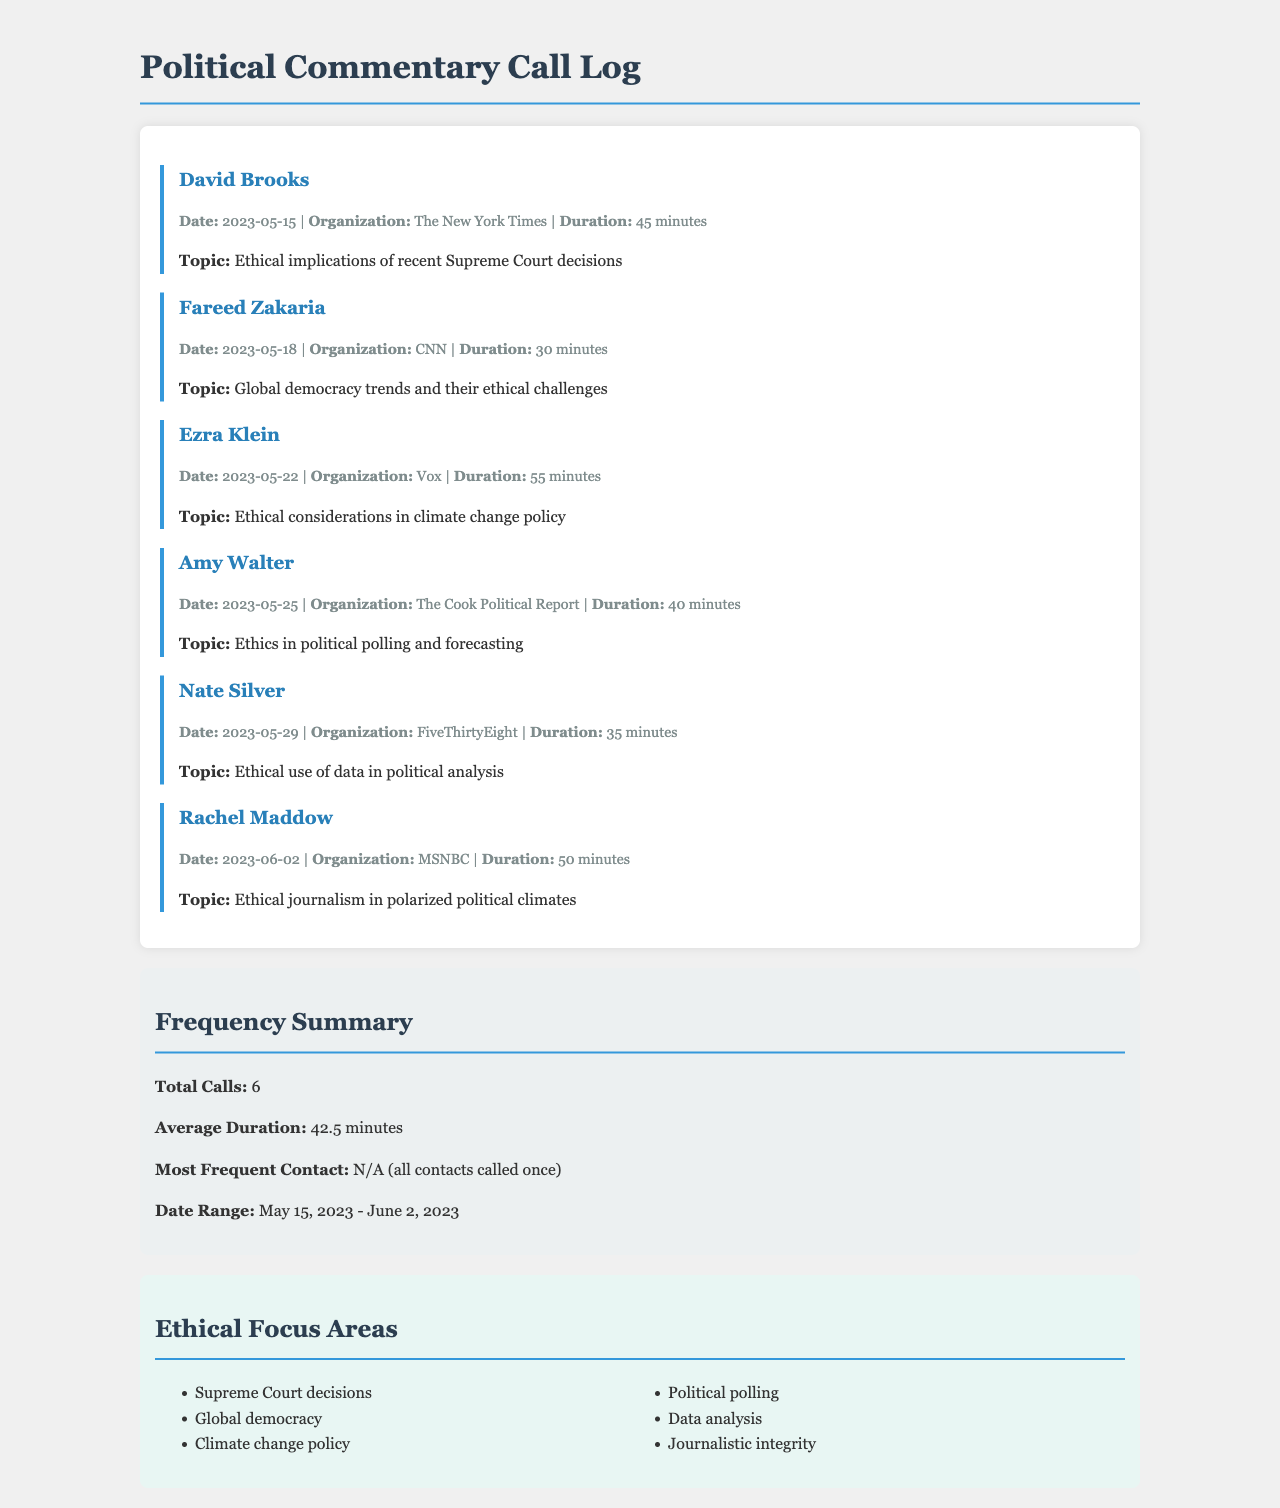What is the duration of the call with David Brooks? The duration of the call is mentioned directly after his name and is 45 minutes.
Answer: 45 minutes Who is the most frequent contact in the call log? The document states that all contacts were called once, hence there is no most frequent contact.
Answer: N/A What was the topic discussed with Rachel Maddow? The topic of her call is provided right after the call details, focusing on ethical journalism.
Answer: Ethical journalism in polarized political climates How many total calls were made according to the log? The total calls are summarized under "Frequency Summary" in the document as 6.
Answer: 6 What is the average duration of all calls? The average duration is calculated and stated in the "Frequency Summary" section as 42.5 minutes.
Answer: 42.5 minutes Which organization was Fareed Zakaria associated with? The organization is provided in the call details section beneath his name, which is CNN.
Answer: CNN What is one ethical focus area mentioned in the log? The ethical focus areas are listed in the corresponding section, and one of them includes Supreme Court decisions.
Answer: Supreme Court decisions On what date did the call with Ezra Klein take place? The date of the call is noted directly in the call details section related to Ezra Klein, which is May 22, 2023.
Answer: 2023-05-22 